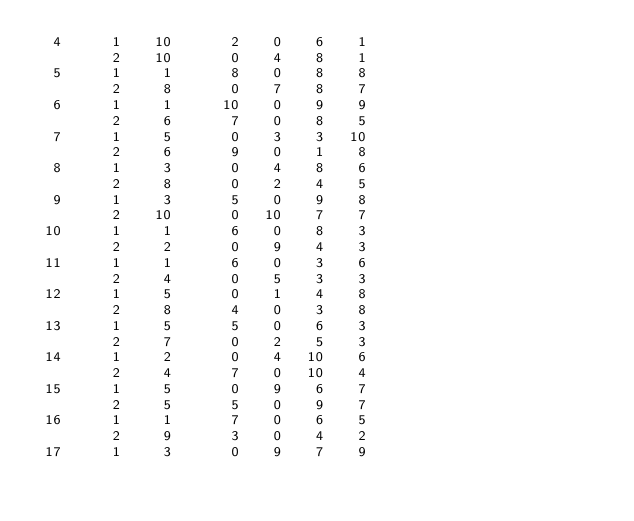<code> <loc_0><loc_0><loc_500><loc_500><_ObjectiveC_>  4      1    10       2    0    6    1
         2    10       0    4    8    1
  5      1     1       8    0    8    8
         2     8       0    7    8    7
  6      1     1      10    0    9    9
         2     6       7    0    8    5
  7      1     5       0    3    3   10
         2     6       9    0    1    8
  8      1     3       0    4    8    6
         2     8       0    2    4    5
  9      1     3       5    0    9    8
         2    10       0   10    7    7
 10      1     1       6    0    8    3
         2     2       0    9    4    3
 11      1     1       6    0    3    6
         2     4       0    5    3    3
 12      1     5       0    1    4    8
         2     8       4    0    3    8
 13      1     5       5    0    6    3
         2     7       0    2    5    3
 14      1     2       0    4   10    6
         2     4       7    0   10    4
 15      1     5       0    9    6    7
         2     5       5    0    9    7
 16      1     1       7    0    6    5
         2     9       3    0    4    2
 17      1     3       0    9    7    9</code> 